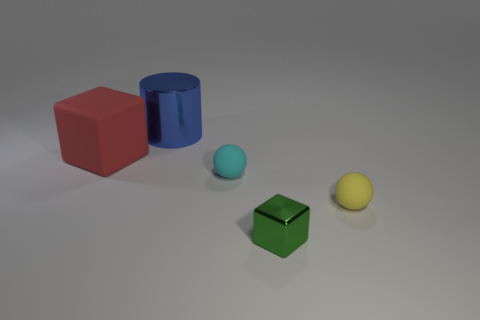Add 5 tiny matte blocks. How many objects exist? 10 Subtract all cubes. How many objects are left? 3 Add 3 matte objects. How many matte objects are left? 6 Add 3 large gray shiny balls. How many large gray shiny balls exist? 3 Subtract 0 red balls. How many objects are left? 5 Subtract all cylinders. Subtract all things. How many objects are left? 3 